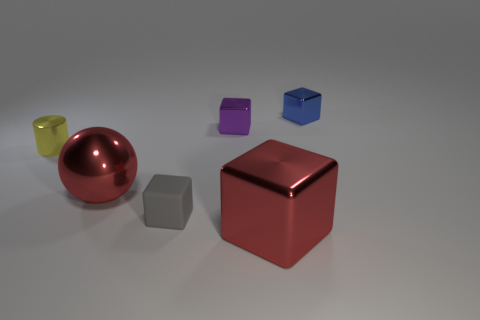What number of red spheres have the same material as the tiny purple thing?
Provide a succinct answer. 1. There is a gray rubber object; is its shape the same as the large shiny thing that is in front of the small gray cube?
Make the answer very short. Yes. Is there a purple object left of the small cube that is in front of the red metal object that is behind the large red metallic cube?
Provide a succinct answer. No. There is a metallic thing that is in front of the red shiny sphere; what size is it?
Keep it short and to the point. Large. What material is the yellow cylinder that is the same size as the gray object?
Give a very brief answer. Metal. Is the purple thing the same shape as the tiny blue object?
Your answer should be very brief. Yes. What number of things are big red metallic cubes or tiny objects on the right side of the rubber thing?
Give a very brief answer. 3. What material is the big block that is the same color as the metallic ball?
Give a very brief answer. Metal. There is a metal thing to the left of the shiny sphere; does it have the same size as the big red sphere?
Your answer should be very brief. No. There is a metal cube behind the tiny metal cube that is left of the blue shiny object; what number of tiny cubes are in front of it?
Keep it short and to the point. 2. 